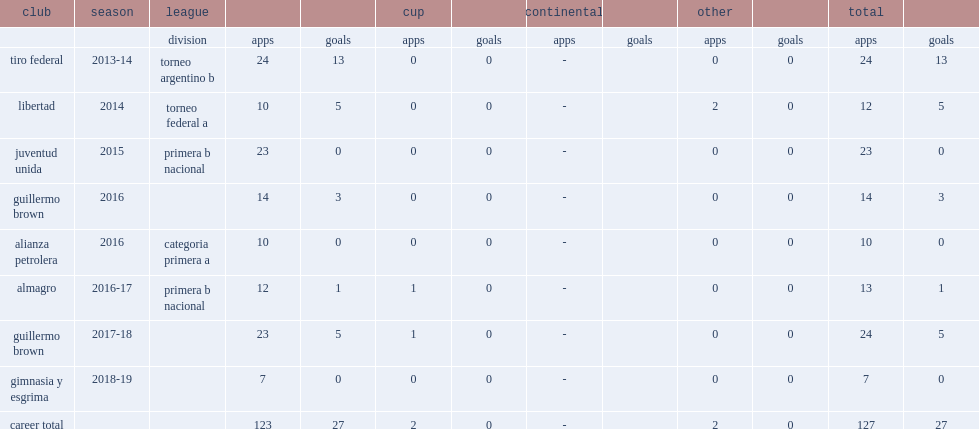How many goals did acosta score in tiro federal during the 2013-14 season? 13.0. 